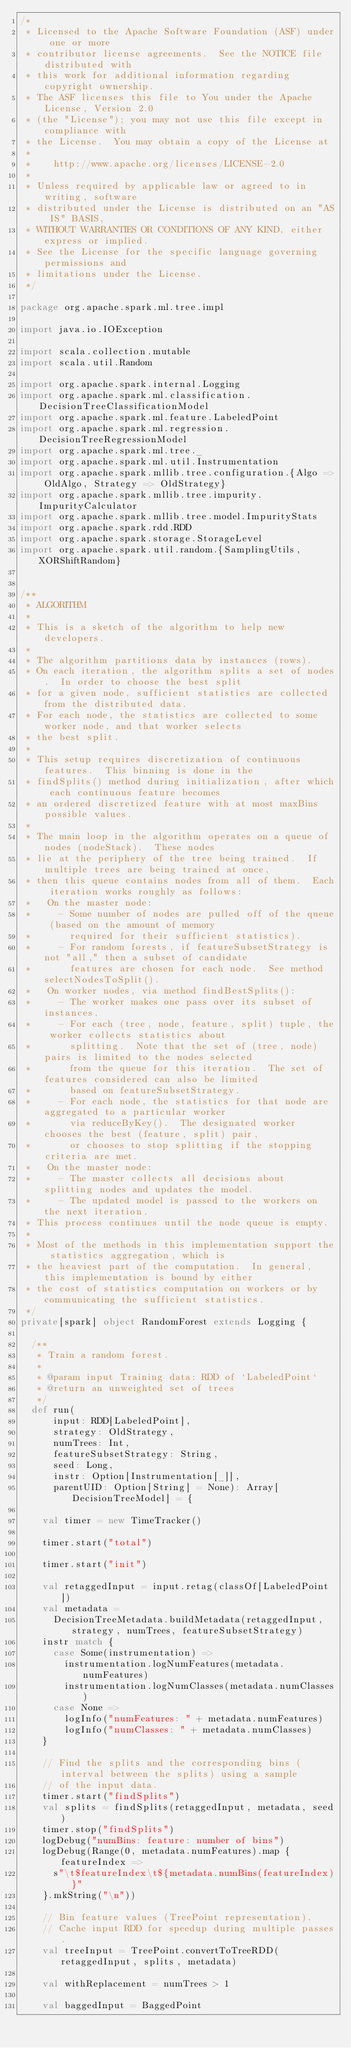Convert code to text. <code><loc_0><loc_0><loc_500><loc_500><_Scala_>/*
 * Licensed to the Apache Software Foundation (ASF) under one or more
 * contributor license agreements.  See the NOTICE file distributed with
 * this work for additional information regarding copyright ownership.
 * The ASF licenses this file to You under the Apache License, Version 2.0
 * (the "License"); you may not use this file except in compliance with
 * the License.  You may obtain a copy of the License at
 *
 *    http://www.apache.org/licenses/LICENSE-2.0
 *
 * Unless required by applicable law or agreed to in writing, software
 * distributed under the License is distributed on an "AS IS" BASIS,
 * WITHOUT WARRANTIES OR CONDITIONS OF ANY KIND, either express or implied.
 * See the License for the specific language governing permissions and
 * limitations under the License.
 */

package org.apache.spark.ml.tree.impl

import java.io.IOException

import scala.collection.mutable
import scala.util.Random

import org.apache.spark.internal.Logging
import org.apache.spark.ml.classification.DecisionTreeClassificationModel
import org.apache.spark.ml.feature.LabeledPoint
import org.apache.spark.ml.regression.DecisionTreeRegressionModel
import org.apache.spark.ml.tree._
import org.apache.spark.ml.util.Instrumentation
import org.apache.spark.mllib.tree.configuration.{Algo => OldAlgo, Strategy => OldStrategy}
import org.apache.spark.mllib.tree.impurity.ImpurityCalculator
import org.apache.spark.mllib.tree.model.ImpurityStats
import org.apache.spark.rdd.RDD
import org.apache.spark.storage.StorageLevel
import org.apache.spark.util.random.{SamplingUtils, XORShiftRandom}


/**
 * ALGORITHM
 *
 * This is a sketch of the algorithm to help new developers.
 *
 * The algorithm partitions data by instances (rows).
 * On each iteration, the algorithm splits a set of nodes.  In order to choose the best split
 * for a given node, sufficient statistics are collected from the distributed data.
 * For each node, the statistics are collected to some worker node, and that worker selects
 * the best split.
 *
 * This setup requires discretization of continuous features.  This binning is done in the
 * findSplits() method during initialization, after which each continuous feature becomes
 * an ordered discretized feature with at most maxBins possible values.
 *
 * The main loop in the algorithm operates on a queue of nodes (nodeStack).  These nodes
 * lie at the periphery of the tree being trained.  If multiple trees are being trained at once,
 * then this queue contains nodes from all of them.  Each iteration works roughly as follows:
 *   On the master node:
 *     - Some number of nodes are pulled off of the queue (based on the amount of memory
 *       required for their sufficient statistics).
 *     - For random forests, if featureSubsetStrategy is not "all," then a subset of candidate
 *       features are chosen for each node.  See method selectNodesToSplit().
 *   On worker nodes, via method findBestSplits():
 *     - The worker makes one pass over its subset of instances.
 *     - For each (tree, node, feature, split) tuple, the worker collects statistics about
 *       splitting.  Note that the set of (tree, node) pairs is limited to the nodes selected
 *       from the queue for this iteration.  The set of features considered can also be limited
 *       based on featureSubsetStrategy.
 *     - For each node, the statistics for that node are aggregated to a particular worker
 *       via reduceByKey().  The designated worker chooses the best (feature, split) pair,
 *       or chooses to stop splitting if the stopping criteria are met.
 *   On the master node:
 *     - The master collects all decisions about splitting nodes and updates the model.
 *     - The updated model is passed to the workers on the next iteration.
 * This process continues until the node queue is empty.
 *
 * Most of the methods in this implementation support the statistics aggregation, which is
 * the heaviest part of the computation.  In general, this implementation is bound by either
 * the cost of statistics computation on workers or by communicating the sufficient statistics.
 */
private[spark] object RandomForest extends Logging {

  /**
   * Train a random forest.
   *
   * @param input Training data: RDD of `LabeledPoint`
   * @return an unweighted set of trees
   */
  def run(
      input: RDD[LabeledPoint],
      strategy: OldStrategy,
      numTrees: Int,
      featureSubsetStrategy: String,
      seed: Long,
      instr: Option[Instrumentation[_]],
      parentUID: Option[String] = None): Array[DecisionTreeModel] = {

    val timer = new TimeTracker()

    timer.start("total")

    timer.start("init")

    val retaggedInput = input.retag(classOf[LabeledPoint])
    val metadata =
      DecisionTreeMetadata.buildMetadata(retaggedInput, strategy, numTrees, featureSubsetStrategy)
    instr match {
      case Some(instrumentation) =>
        instrumentation.logNumFeatures(metadata.numFeatures)
        instrumentation.logNumClasses(metadata.numClasses)
      case None =>
        logInfo("numFeatures: " + metadata.numFeatures)
        logInfo("numClasses: " + metadata.numClasses)
    }

    // Find the splits and the corresponding bins (interval between the splits) using a sample
    // of the input data.
    timer.start("findSplits")
    val splits = findSplits(retaggedInput, metadata, seed)
    timer.stop("findSplits")
    logDebug("numBins: feature: number of bins")
    logDebug(Range(0, metadata.numFeatures).map { featureIndex =>
      s"\t$featureIndex\t${metadata.numBins(featureIndex)}"
    }.mkString("\n"))

    // Bin feature values (TreePoint representation).
    // Cache input RDD for speedup during multiple passes.
    val treeInput = TreePoint.convertToTreeRDD(retaggedInput, splits, metadata)

    val withReplacement = numTrees > 1

    val baggedInput = BaggedPoint</code> 